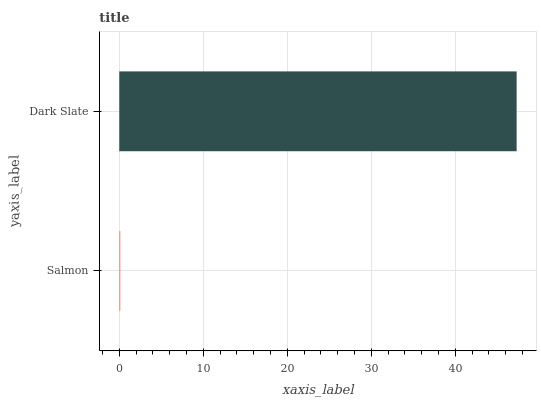Is Salmon the minimum?
Answer yes or no. Yes. Is Dark Slate the maximum?
Answer yes or no. Yes. Is Dark Slate the minimum?
Answer yes or no. No. Is Dark Slate greater than Salmon?
Answer yes or no. Yes. Is Salmon less than Dark Slate?
Answer yes or no. Yes. Is Salmon greater than Dark Slate?
Answer yes or no. No. Is Dark Slate less than Salmon?
Answer yes or no. No. Is Dark Slate the high median?
Answer yes or no. Yes. Is Salmon the low median?
Answer yes or no. Yes. Is Salmon the high median?
Answer yes or no. No. Is Dark Slate the low median?
Answer yes or no. No. 